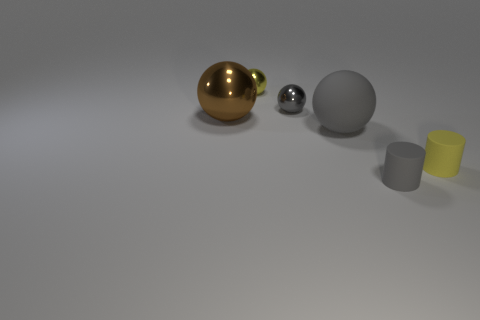What is the color of the matte thing that is behind the small cylinder that is behind the gray rubber thing that is to the right of the big matte sphere?
Offer a terse response. Gray. The small thing that is to the left of the tiny yellow cylinder and in front of the big matte ball has what shape?
Keep it short and to the point. Cylinder. Are there any other things that are the same size as the yellow rubber cylinder?
Make the answer very short. Yes. What color is the large ball in front of the big ball left of the matte ball?
Your answer should be compact. Gray. What is the shape of the metal object on the left side of the yellow object that is behind the big ball that is right of the yellow shiny thing?
Offer a terse response. Sphere. What size is the sphere that is both on the left side of the tiny gray shiny object and in front of the tiny gray metal thing?
Offer a very short reply. Large. What number of big metal balls have the same color as the big shiny object?
Provide a short and direct response. 0. What material is the small sphere that is the same color as the big matte object?
Make the answer very short. Metal. What is the brown sphere made of?
Your response must be concise. Metal. Is the material of the large thing that is in front of the large brown shiny sphere the same as the small gray sphere?
Your answer should be very brief. No. 